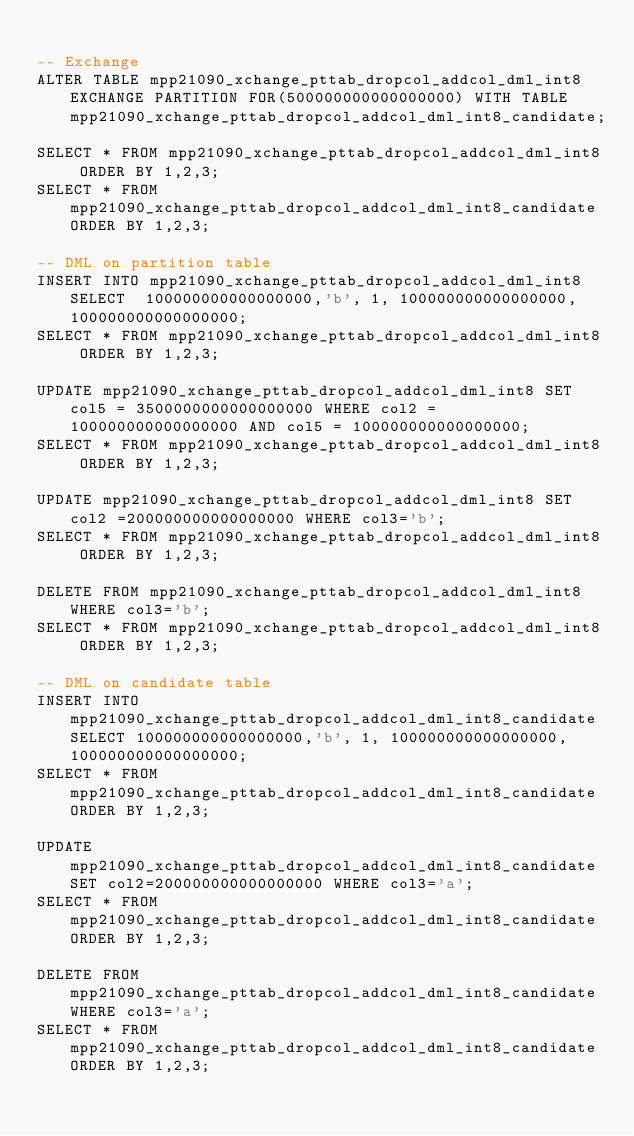<code> <loc_0><loc_0><loc_500><loc_500><_SQL_>
-- Exchange 
ALTER TABLE mpp21090_xchange_pttab_dropcol_addcol_dml_int8 EXCHANGE PARTITION FOR(500000000000000000) WITH TABLE mpp21090_xchange_pttab_dropcol_addcol_dml_int8_candidate;

SELECT * FROM mpp21090_xchange_pttab_dropcol_addcol_dml_int8 ORDER BY 1,2,3;
SELECT * FROM mpp21090_xchange_pttab_dropcol_addcol_dml_int8_candidate ORDER BY 1,2,3;

-- DML on partition table
INSERT INTO mpp21090_xchange_pttab_dropcol_addcol_dml_int8 SELECT  100000000000000000,'b', 1, 100000000000000000, 100000000000000000;
SELECT * FROM mpp21090_xchange_pttab_dropcol_addcol_dml_int8 ORDER BY 1,2,3;

UPDATE mpp21090_xchange_pttab_dropcol_addcol_dml_int8 SET col5 = 3500000000000000000 WHERE col2 = 100000000000000000 AND col5 = 100000000000000000;
SELECT * FROM mpp21090_xchange_pttab_dropcol_addcol_dml_int8 ORDER BY 1,2,3;

UPDATE mpp21090_xchange_pttab_dropcol_addcol_dml_int8 SET col2 =200000000000000000 WHERE col3='b';
SELECT * FROM mpp21090_xchange_pttab_dropcol_addcol_dml_int8 ORDER BY 1,2,3;

DELETE FROM mpp21090_xchange_pttab_dropcol_addcol_dml_int8 WHERE col3='b';
SELECT * FROM mpp21090_xchange_pttab_dropcol_addcol_dml_int8 ORDER BY 1,2,3;

-- DML on candidate table
INSERT INTO mpp21090_xchange_pttab_dropcol_addcol_dml_int8_candidate SELECT 100000000000000000,'b', 1, 100000000000000000, 100000000000000000;
SELECT * FROM mpp21090_xchange_pttab_dropcol_addcol_dml_int8_candidate ORDER BY 1,2,3;

UPDATE mpp21090_xchange_pttab_dropcol_addcol_dml_int8_candidate SET col2=200000000000000000 WHERE col3='a';
SELECT * FROM mpp21090_xchange_pttab_dropcol_addcol_dml_int8_candidate ORDER BY 1,2,3;

DELETE FROM mpp21090_xchange_pttab_dropcol_addcol_dml_int8_candidate WHERE col3='a';
SELECT * FROM mpp21090_xchange_pttab_dropcol_addcol_dml_int8_candidate ORDER BY 1,2,3;
</code> 